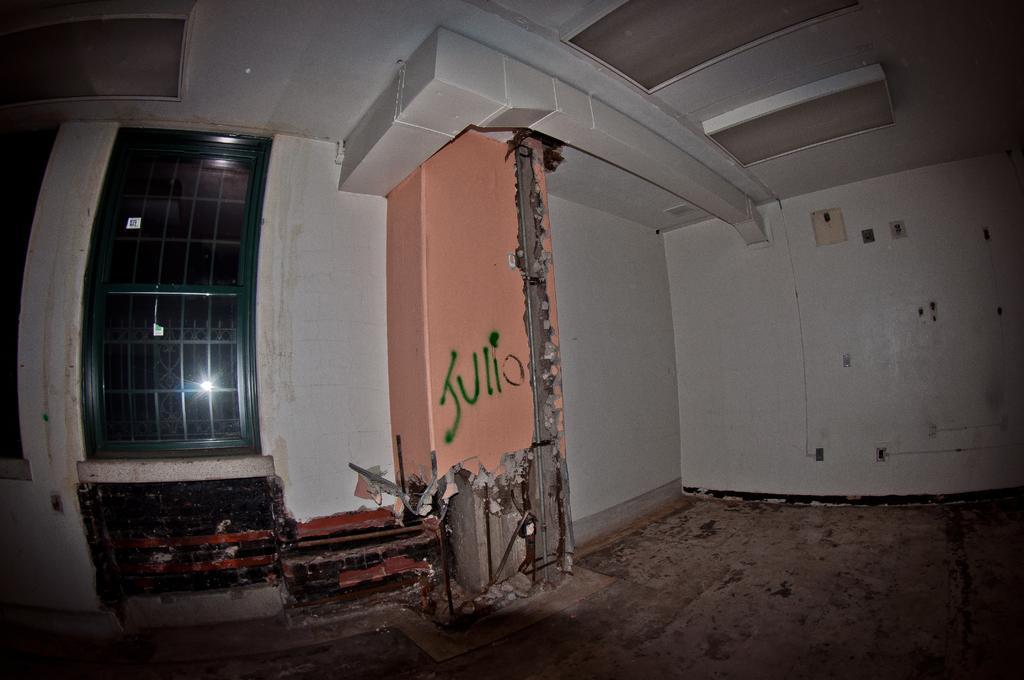Can you describe this image briefly? In the center of the image there is a wall, window and some objects. And we can see some text on the wall. 